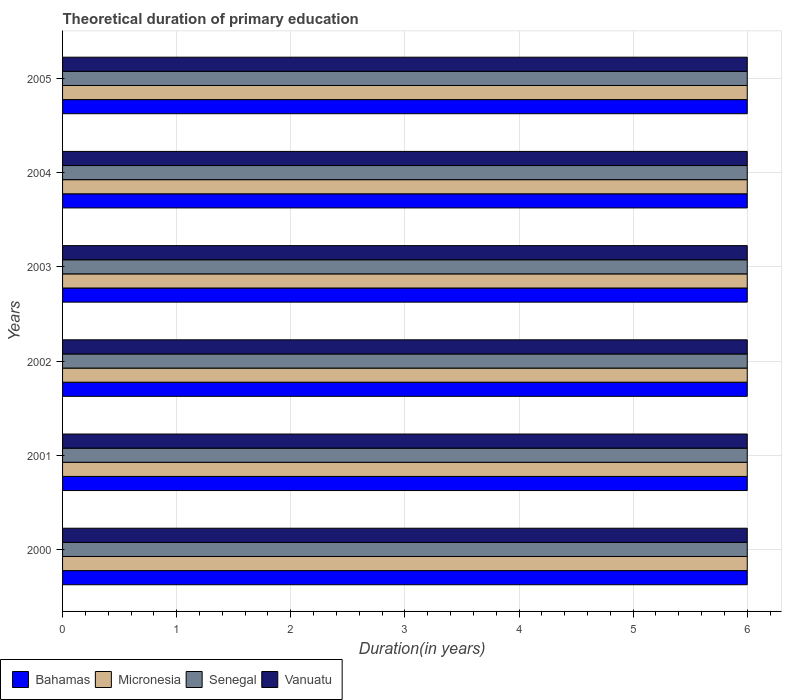How many groups of bars are there?
Make the answer very short. 6. Are the number of bars on each tick of the Y-axis equal?
Your answer should be compact. Yes. What is the label of the 3rd group of bars from the top?
Give a very brief answer. 2003. Across all years, what is the maximum total theoretical duration of primary education in Vanuatu?
Your response must be concise. 6. In which year was the total theoretical duration of primary education in Senegal minimum?
Provide a succinct answer. 2000. What is the total total theoretical duration of primary education in Vanuatu in the graph?
Offer a terse response. 36. What is the difference between the total theoretical duration of primary education in Vanuatu in 2000 and that in 2004?
Offer a terse response. 0. What is the difference between the total theoretical duration of primary education in Bahamas in 2003 and the total theoretical duration of primary education in Senegal in 2002?
Give a very brief answer. 0. In the year 2001, what is the difference between the total theoretical duration of primary education in Micronesia and total theoretical duration of primary education in Senegal?
Your answer should be compact. 0. What is the ratio of the total theoretical duration of primary education in Micronesia in 2003 to that in 2005?
Give a very brief answer. 1. What is the difference between the highest and the second highest total theoretical duration of primary education in Micronesia?
Your answer should be very brief. 0. What is the difference between the highest and the lowest total theoretical duration of primary education in Micronesia?
Provide a short and direct response. 0. In how many years, is the total theoretical duration of primary education in Vanuatu greater than the average total theoretical duration of primary education in Vanuatu taken over all years?
Provide a short and direct response. 0. Is it the case that in every year, the sum of the total theoretical duration of primary education in Micronesia and total theoretical duration of primary education in Bahamas is greater than the sum of total theoretical duration of primary education in Vanuatu and total theoretical duration of primary education in Senegal?
Provide a short and direct response. No. What does the 3rd bar from the top in 2003 represents?
Your answer should be very brief. Micronesia. What does the 1st bar from the bottom in 2000 represents?
Give a very brief answer. Bahamas. Is it the case that in every year, the sum of the total theoretical duration of primary education in Vanuatu and total theoretical duration of primary education in Senegal is greater than the total theoretical duration of primary education in Bahamas?
Offer a terse response. Yes. How many bars are there?
Provide a short and direct response. 24. What is the difference between two consecutive major ticks on the X-axis?
Ensure brevity in your answer.  1. Does the graph contain any zero values?
Make the answer very short. No. Does the graph contain grids?
Provide a succinct answer. Yes. Where does the legend appear in the graph?
Give a very brief answer. Bottom left. What is the title of the graph?
Provide a succinct answer. Theoretical duration of primary education. What is the label or title of the X-axis?
Your answer should be compact. Duration(in years). What is the label or title of the Y-axis?
Make the answer very short. Years. What is the Duration(in years) in Bahamas in 2001?
Provide a succinct answer. 6. What is the Duration(in years) of Micronesia in 2001?
Your answer should be compact. 6. What is the Duration(in years) in Vanuatu in 2001?
Offer a terse response. 6. What is the Duration(in years) in Bahamas in 2002?
Make the answer very short. 6. What is the Duration(in years) in Micronesia in 2002?
Ensure brevity in your answer.  6. What is the Duration(in years) in Bahamas in 2003?
Your response must be concise. 6. What is the Duration(in years) in Senegal in 2003?
Keep it short and to the point. 6. What is the Duration(in years) of Bahamas in 2004?
Provide a succinct answer. 6. What is the Duration(in years) of Micronesia in 2004?
Your answer should be compact. 6. What is the Duration(in years) of Vanuatu in 2004?
Provide a short and direct response. 6. What is the Duration(in years) of Micronesia in 2005?
Offer a terse response. 6. What is the Duration(in years) in Senegal in 2005?
Your response must be concise. 6. What is the Duration(in years) of Vanuatu in 2005?
Offer a terse response. 6. Across all years, what is the maximum Duration(in years) of Micronesia?
Your answer should be compact. 6. Across all years, what is the maximum Duration(in years) of Vanuatu?
Make the answer very short. 6. Across all years, what is the minimum Duration(in years) in Bahamas?
Your response must be concise. 6. Across all years, what is the minimum Duration(in years) in Senegal?
Your response must be concise. 6. Across all years, what is the minimum Duration(in years) of Vanuatu?
Your answer should be very brief. 6. What is the total Duration(in years) of Bahamas in the graph?
Your response must be concise. 36. What is the total Duration(in years) of Vanuatu in the graph?
Ensure brevity in your answer.  36. What is the difference between the Duration(in years) in Bahamas in 2000 and that in 2001?
Give a very brief answer. 0. What is the difference between the Duration(in years) of Micronesia in 2000 and that in 2001?
Provide a short and direct response. 0. What is the difference between the Duration(in years) of Senegal in 2000 and that in 2001?
Give a very brief answer. 0. What is the difference between the Duration(in years) in Bahamas in 2000 and that in 2002?
Your answer should be very brief. 0. What is the difference between the Duration(in years) of Micronesia in 2000 and that in 2002?
Make the answer very short. 0. What is the difference between the Duration(in years) of Senegal in 2000 and that in 2002?
Offer a terse response. 0. What is the difference between the Duration(in years) in Vanuatu in 2000 and that in 2002?
Give a very brief answer. 0. What is the difference between the Duration(in years) in Bahamas in 2000 and that in 2003?
Give a very brief answer. 0. What is the difference between the Duration(in years) of Micronesia in 2000 and that in 2003?
Provide a short and direct response. 0. What is the difference between the Duration(in years) in Senegal in 2000 and that in 2004?
Your answer should be very brief. 0. What is the difference between the Duration(in years) in Vanuatu in 2000 and that in 2004?
Offer a terse response. 0. What is the difference between the Duration(in years) in Bahamas in 2000 and that in 2005?
Ensure brevity in your answer.  0. What is the difference between the Duration(in years) in Micronesia in 2000 and that in 2005?
Your answer should be compact. 0. What is the difference between the Duration(in years) in Senegal in 2000 and that in 2005?
Provide a succinct answer. 0. What is the difference between the Duration(in years) in Vanuatu in 2000 and that in 2005?
Give a very brief answer. 0. What is the difference between the Duration(in years) of Bahamas in 2001 and that in 2002?
Your answer should be very brief. 0. What is the difference between the Duration(in years) of Senegal in 2001 and that in 2002?
Your answer should be compact. 0. What is the difference between the Duration(in years) of Micronesia in 2001 and that in 2003?
Keep it short and to the point. 0. What is the difference between the Duration(in years) in Senegal in 2001 and that in 2004?
Offer a terse response. 0. What is the difference between the Duration(in years) in Vanuatu in 2001 and that in 2004?
Offer a very short reply. 0. What is the difference between the Duration(in years) of Senegal in 2001 and that in 2005?
Offer a terse response. 0. What is the difference between the Duration(in years) in Micronesia in 2002 and that in 2003?
Your answer should be compact. 0. What is the difference between the Duration(in years) in Bahamas in 2002 and that in 2004?
Ensure brevity in your answer.  0. What is the difference between the Duration(in years) of Micronesia in 2002 and that in 2004?
Make the answer very short. 0. What is the difference between the Duration(in years) in Senegal in 2002 and that in 2004?
Make the answer very short. 0. What is the difference between the Duration(in years) in Vanuatu in 2002 and that in 2004?
Your response must be concise. 0. What is the difference between the Duration(in years) of Bahamas in 2002 and that in 2005?
Give a very brief answer. 0. What is the difference between the Duration(in years) in Micronesia in 2002 and that in 2005?
Offer a very short reply. 0. What is the difference between the Duration(in years) in Senegal in 2002 and that in 2005?
Make the answer very short. 0. What is the difference between the Duration(in years) of Bahamas in 2003 and that in 2004?
Provide a succinct answer. 0. What is the difference between the Duration(in years) of Senegal in 2003 and that in 2004?
Offer a terse response. 0. What is the difference between the Duration(in years) of Bahamas in 2003 and that in 2005?
Your answer should be very brief. 0. What is the difference between the Duration(in years) of Micronesia in 2003 and that in 2005?
Your response must be concise. 0. What is the difference between the Duration(in years) in Micronesia in 2004 and that in 2005?
Provide a short and direct response. 0. What is the difference between the Duration(in years) in Bahamas in 2000 and the Duration(in years) in Senegal in 2001?
Your response must be concise. 0. What is the difference between the Duration(in years) in Bahamas in 2000 and the Duration(in years) in Vanuatu in 2001?
Ensure brevity in your answer.  0. What is the difference between the Duration(in years) in Micronesia in 2000 and the Duration(in years) in Vanuatu in 2001?
Your response must be concise. 0. What is the difference between the Duration(in years) in Bahamas in 2000 and the Duration(in years) in Micronesia in 2002?
Offer a very short reply. 0. What is the difference between the Duration(in years) of Bahamas in 2000 and the Duration(in years) of Senegal in 2002?
Provide a succinct answer. 0. What is the difference between the Duration(in years) in Bahamas in 2000 and the Duration(in years) in Vanuatu in 2002?
Offer a terse response. 0. What is the difference between the Duration(in years) of Micronesia in 2000 and the Duration(in years) of Vanuatu in 2002?
Provide a succinct answer. 0. What is the difference between the Duration(in years) of Bahamas in 2000 and the Duration(in years) of Micronesia in 2003?
Your answer should be very brief. 0. What is the difference between the Duration(in years) of Micronesia in 2000 and the Duration(in years) of Senegal in 2003?
Offer a very short reply. 0. What is the difference between the Duration(in years) in Micronesia in 2000 and the Duration(in years) in Vanuatu in 2003?
Your answer should be very brief. 0. What is the difference between the Duration(in years) of Bahamas in 2000 and the Duration(in years) of Senegal in 2004?
Ensure brevity in your answer.  0. What is the difference between the Duration(in years) in Bahamas in 2000 and the Duration(in years) in Vanuatu in 2004?
Offer a very short reply. 0. What is the difference between the Duration(in years) of Senegal in 2000 and the Duration(in years) of Vanuatu in 2004?
Offer a terse response. 0. What is the difference between the Duration(in years) of Bahamas in 2000 and the Duration(in years) of Vanuatu in 2005?
Provide a succinct answer. 0. What is the difference between the Duration(in years) in Bahamas in 2001 and the Duration(in years) in Senegal in 2002?
Your response must be concise. 0. What is the difference between the Duration(in years) in Micronesia in 2001 and the Duration(in years) in Vanuatu in 2002?
Give a very brief answer. 0. What is the difference between the Duration(in years) in Bahamas in 2001 and the Duration(in years) in Micronesia in 2003?
Your answer should be compact. 0. What is the difference between the Duration(in years) in Micronesia in 2001 and the Duration(in years) in Vanuatu in 2003?
Keep it short and to the point. 0. What is the difference between the Duration(in years) in Bahamas in 2001 and the Duration(in years) in Senegal in 2004?
Your answer should be compact. 0. What is the difference between the Duration(in years) in Bahamas in 2001 and the Duration(in years) in Vanuatu in 2004?
Your answer should be compact. 0. What is the difference between the Duration(in years) in Micronesia in 2001 and the Duration(in years) in Senegal in 2004?
Your answer should be very brief. 0. What is the difference between the Duration(in years) of Bahamas in 2001 and the Duration(in years) of Micronesia in 2005?
Keep it short and to the point. 0. What is the difference between the Duration(in years) of Micronesia in 2001 and the Duration(in years) of Vanuatu in 2005?
Ensure brevity in your answer.  0. What is the difference between the Duration(in years) of Senegal in 2001 and the Duration(in years) of Vanuatu in 2005?
Provide a short and direct response. 0. What is the difference between the Duration(in years) in Bahamas in 2002 and the Duration(in years) in Micronesia in 2003?
Provide a succinct answer. 0. What is the difference between the Duration(in years) of Bahamas in 2002 and the Duration(in years) of Vanuatu in 2003?
Give a very brief answer. 0. What is the difference between the Duration(in years) in Micronesia in 2002 and the Duration(in years) in Vanuatu in 2003?
Your answer should be compact. 0. What is the difference between the Duration(in years) of Senegal in 2002 and the Duration(in years) of Vanuatu in 2003?
Offer a terse response. 0. What is the difference between the Duration(in years) in Bahamas in 2002 and the Duration(in years) in Vanuatu in 2004?
Offer a very short reply. 0. What is the difference between the Duration(in years) in Micronesia in 2002 and the Duration(in years) in Vanuatu in 2004?
Your response must be concise. 0. What is the difference between the Duration(in years) in Bahamas in 2002 and the Duration(in years) in Micronesia in 2005?
Provide a succinct answer. 0. What is the difference between the Duration(in years) in Bahamas in 2002 and the Duration(in years) in Senegal in 2005?
Provide a succinct answer. 0. What is the difference between the Duration(in years) of Senegal in 2002 and the Duration(in years) of Vanuatu in 2005?
Your answer should be very brief. 0. What is the difference between the Duration(in years) in Bahamas in 2003 and the Duration(in years) in Vanuatu in 2004?
Provide a succinct answer. 0. What is the difference between the Duration(in years) of Bahamas in 2003 and the Duration(in years) of Senegal in 2005?
Provide a short and direct response. 0. What is the difference between the Duration(in years) in Bahamas in 2003 and the Duration(in years) in Vanuatu in 2005?
Your answer should be very brief. 0. What is the difference between the Duration(in years) in Micronesia in 2003 and the Duration(in years) in Senegal in 2005?
Your answer should be compact. 0. What is the difference between the Duration(in years) in Senegal in 2003 and the Duration(in years) in Vanuatu in 2005?
Your answer should be compact. 0. What is the difference between the Duration(in years) of Bahamas in 2004 and the Duration(in years) of Vanuatu in 2005?
Your answer should be very brief. 0. What is the difference between the Duration(in years) in Senegal in 2004 and the Duration(in years) in Vanuatu in 2005?
Ensure brevity in your answer.  0. What is the average Duration(in years) of Senegal per year?
Your answer should be very brief. 6. What is the average Duration(in years) in Vanuatu per year?
Keep it short and to the point. 6. In the year 2000, what is the difference between the Duration(in years) of Bahamas and Duration(in years) of Micronesia?
Ensure brevity in your answer.  0. In the year 2000, what is the difference between the Duration(in years) in Bahamas and Duration(in years) in Vanuatu?
Provide a short and direct response. 0. In the year 2000, what is the difference between the Duration(in years) of Micronesia and Duration(in years) of Senegal?
Offer a terse response. 0. In the year 2000, what is the difference between the Duration(in years) in Micronesia and Duration(in years) in Vanuatu?
Your answer should be very brief. 0. In the year 2001, what is the difference between the Duration(in years) in Bahamas and Duration(in years) in Senegal?
Offer a terse response. 0. In the year 2001, what is the difference between the Duration(in years) in Senegal and Duration(in years) in Vanuatu?
Ensure brevity in your answer.  0. In the year 2002, what is the difference between the Duration(in years) in Bahamas and Duration(in years) in Senegal?
Provide a short and direct response. 0. In the year 2002, what is the difference between the Duration(in years) in Bahamas and Duration(in years) in Vanuatu?
Make the answer very short. 0. In the year 2002, what is the difference between the Duration(in years) of Micronesia and Duration(in years) of Senegal?
Make the answer very short. 0. In the year 2002, what is the difference between the Duration(in years) of Senegal and Duration(in years) of Vanuatu?
Provide a short and direct response. 0. In the year 2003, what is the difference between the Duration(in years) in Bahamas and Duration(in years) in Senegal?
Give a very brief answer. 0. In the year 2003, what is the difference between the Duration(in years) in Bahamas and Duration(in years) in Vanuatu?
Ensure brevity in your answer.  0. In the year 2003, what is the difference between the Duration(in years) of Micronesia and Duration(in years) of Vanuatu?
Provide a short and direct response. 0. In the year 2003, what is the difference between the Duration(in years) in Senegal and Duration(in years) in Vanuatu?
Make the answer very short. 0. In the year 2004, what is the difference between the Duration(in years) of Bahamas and Duration(in years) of Senegal?
Provide a succinct answer. 0. In the year 2004, what is the difference between the Duration(in years) of Bahamas and Duration(in years) of Vanuatu?
Provide a succinct answer. 0. In the year 2004, what is the difference between the Duration(in years) in Micronesia and Duration(in years) in Senegal?
Offer a terse response. 0. In the year 2004, what is the difference between the Duration(in years) of Senegal and Duration(in years) of Vanuatu?
Keep it short and to the point. 0. In the year 2005, what is the difference between the Duration(in years) of Bahamas and Duration(in years) of Senegal?
Ensure brevity in your answer.  0. In the year 2005, what is the difference between the Duration(in years) in Micronesia and Duration(in years) in Senegal?
Your answer should be compact. 0. In the year 2005, what is the difference between the Duration(in years) of Micronesia and Duration(in years) of Vanuatu?
Your answer should be compact. 0. What is the ratio of the Duration(in years) of Bahamas in 2000 to that in 2001?
Make the answer very short. 1. What is the ratio of the Duration(in years) in Micronesia in 2000 to that in 2001?
Keep it short and to the point. 1. What is the ratio of the Duration(in years) of Vanuatu in 2000 to that in 2001?
Make the answer very short. 1. What is the ratio of the Duration(in years) in Micronesia in 2000 to that in 2002?
Your response must be concise. 1. What is the ratio of the Duration(in years) in Senegal in 2000 to that in 2002?
Provide a succinct answer. 1. What is the ratio of the Duration(in years) of Vanuatu in 2000 to that in 2002?
Keep it short and to the point. 1. What is the ratio of the Duration(in years) in Micronesia in 2000 to that in 2003?
Make the answer very short. 1. What is the ratio of the Duration(in years) in Senegal in 2000 to that in 2003?
Your answer should be compact. 1. What is the ratio of the Duration(in years) of Bahamas in 2000 to that in 2004?
Your answer should be compact. 1. What is the ratio of the Duration(in years) of Micronesia in 2000 to that in 2004?
Provide a short and direct response. 1. What is the ratio of the Duration(in years) of Senegal in 2000 to that in 2004?
Your answer should be compact. 1. What is the ratio of the Duration(in years) in Vanuatu in 2000 to that in 2004?
Provide a short and direct response. 1. What is the ratio of the Duration(in years) of Bahamas in 2000 to that in 2005?
Your response must be concise. 1. What is the ratio of the Duration(in years) in Micronesia in 2000 to that in 2005?
Your answer should be compact. 1. What is the ratio of the Duration(in years) of Vanuatu in 2000 to that in 2005?
Your answer should be very brief. 1. What is the ratio of the Duration(in years) of Micronesia in 2001 to that in 2002?
Your answer should be very brief. 1. What is the ratio of the Duration(in years) in Senegal in 2001 to that in 2002?
Offer a very short reply. 1. What is the ratio of the Duration(in years) of Vanuatu in 2001 to that in 2002?
Make the answer very short. 1. What is the ratio of the Duration(in years) of Bahamas in 2001 to that in 2003?
Ensure brevity in your answer.  1. What is the ratio of the Duration(in years) of Micronesia in 2001 to that in 2003?
Your answer should be very brief. 1. What is the ratio of the Duration(in years) of Senegal in 2001 to that in 2003?
Give a very brief answer. 1. What is the ratio of the Duration(in years) in Vanuatu in 2001 to that in 2003?
Your response must be concise. 1. What is the ratio of the Duration(in years) in Bahamas in 2001 to that in 2004?
Provide a short and direct response. 1. What is the ratio of the Duration(in years) of Senegal in 2001 to that in 2004?
Ensure brevity in your answer.  1. What is the ratio of the Duration(in years) of Vanuatu in 2001 to that in 2004?
Offer a terse response. 1. What is the ratio of the Duration(in years) in Senegal in 2001 to that in 2005?
Your response must be concise. 1. What is the ratio of the Duration(in years) of Vanuatu in 2001 to that in 2005?
Keep it short and to the point. 1. What is the ratio of the Duration(in years) of Bahamas in 2002 to that in 2003?
Your answer should be compact. 1. What is the ratio of the Duration(in years) in Senegal in 2002 to that in 2003?
Offer a very short reply. 1. What is the ratio of the Duration(in years) in Micronesia in 2002 to that in 2005?
Keep it short and to the point. 1. What is the ratio of the Duration(in years) of Senegal in 2002 to that in 2005?
Give a very brief answer. 1. What is the ratio of the Duration(in years) in Micronesia in 2003 to that in 2004?
Ensure brevity in your answer.  1. What is the ratio of the Duration(in years) of Vanuatu in 2003 to that in 2004?
Offer a very short reply. 1. What is the ratio of the Duration(in years) in Bahamas in 2003 to that in 2005?
Your answer should be compact. 1. What is the ratio of the Duration(in years) of Senegal in 2003 to that in 2005?
Provide a short and direct response. 1. What is the ratio of the Duration(in years) in Vanuatu in 2003 to that in 2005?
Provide a short and direct response. 1. What is the ratio of the Duration(in years) in Bahamas in 2004 to that in 2005?
Make the answer very short. 1. What is the ratio of the Duration(in years) of Vanuatu in 2004 to that in 2005?
Keep it short and to the point. 1. What is the difference between the highest and the second highest Duration(in years) in Bahamas?
Ensure brevity in your answer.  0. What is the difference between the highest and the second highest Duration(in years) in Micronesia?
Your response must be concise. 0. What is the difference between the highest and the second highest Duration(in years) of Senegal?
Provide a short and direct response. 0. What is the difference between the highest and the second highest Duration(in years) in Vanuatu?
Make the answer very short. 0. What is the difference between the highest and the lowest Duration(in years) of Micronesia?
Keep it short and to the point. 0. 